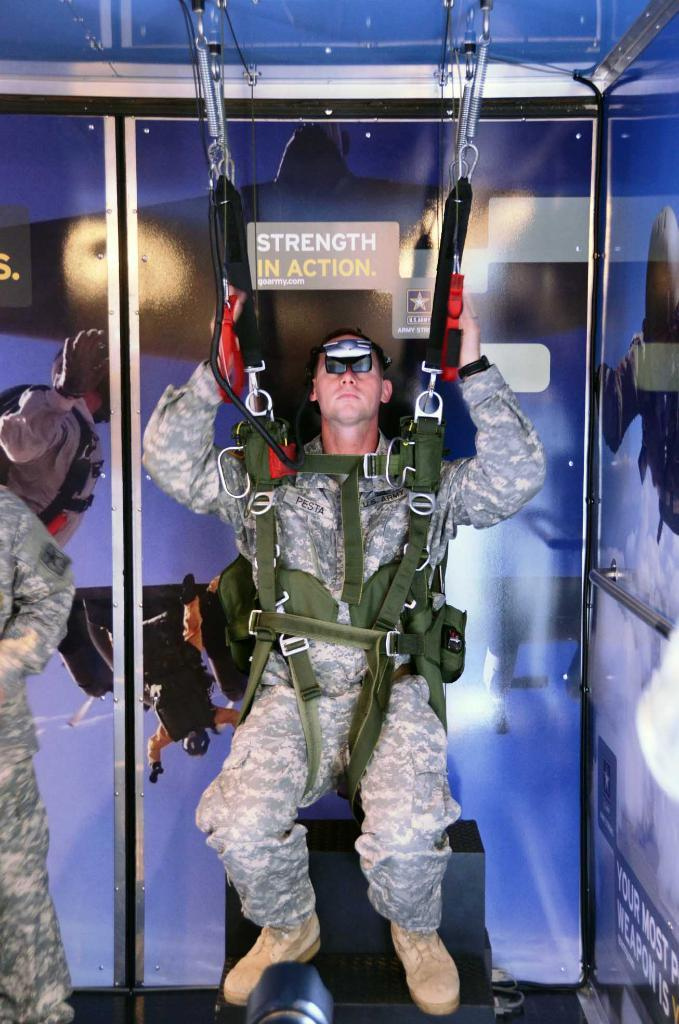What is the main subject of the image? There is a person in the image. What is the person doing in the image? The person is hanging on a harness. What can be seen in the background of the image? There is a wallpaper in the background of the image. What color is the dock in the image? There is no dock present in the image. 